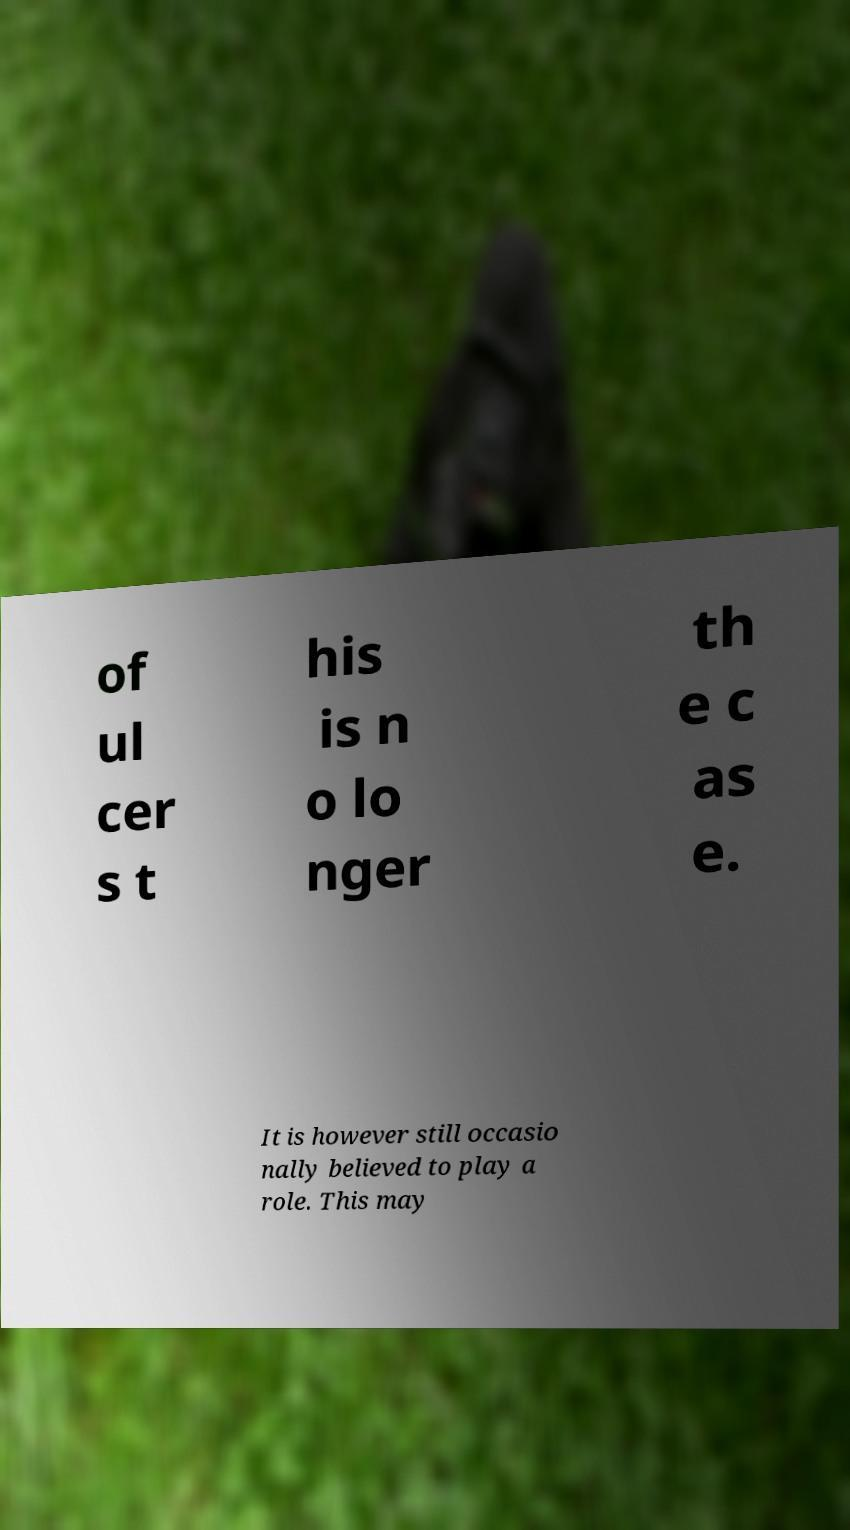What messages or text are displayed in this image? I need them in a readable, typed format. of ul cer s t his is n o lo nger th e c as e. It is however still occasio nally believed to play a role. This may 